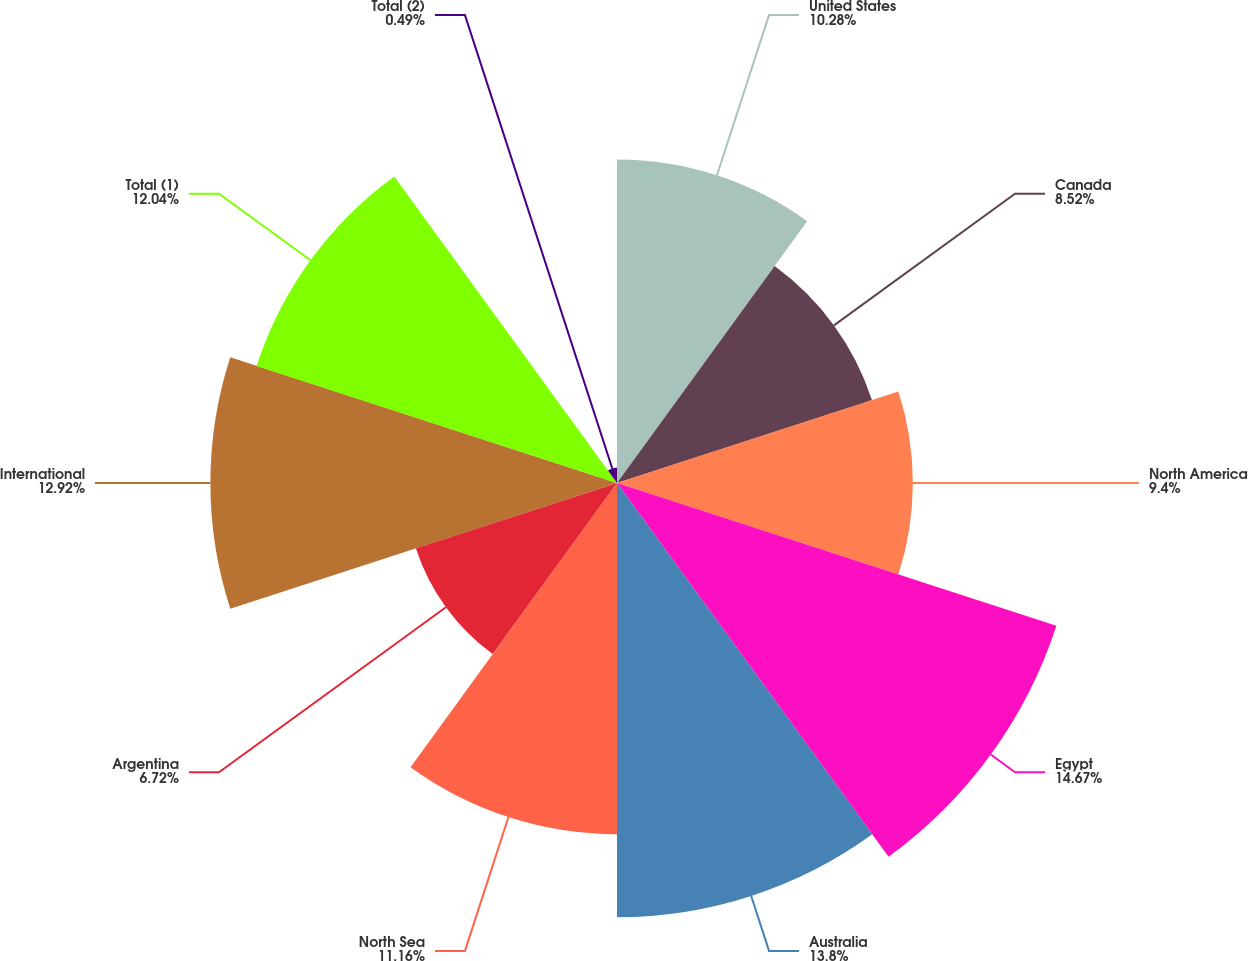Convert chart to OTSL. <chart><loc_0><loc_0><loc_500><loc_500><pie_chart><fcel>United States<fcel>Canada<fcel>North America<fcel>Egypt<fcel>Australia<fcel>North Sea<fcel>Argentina<fcel>International<fcel>Total (1)<fcel>Total (2)<nl><fcel>10.28%<fcel>8.52%<fcel>9.4%<fcel>14.68%<fcel>13.8%<fcel>11.16%<fcel>6.72%<fcel>12.92%<fcel>12.04%<fcel>0.49%<nl></chart> 